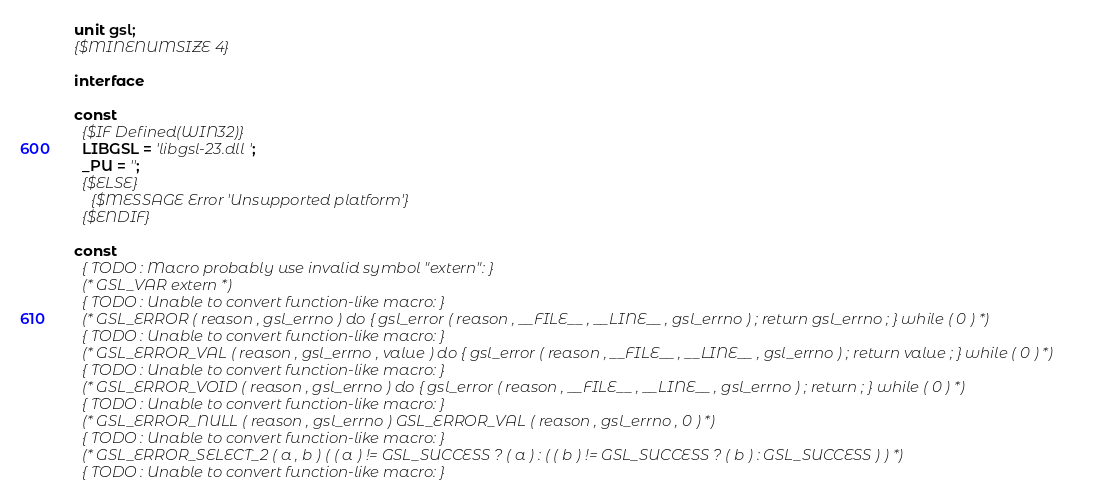Convert code to text. <code><loc_0><loc_0><loc_500><loc_500><_Pascal_>unit gsl;
{$MINENUMSIZE 4}

interface

const
  {$IF Defined(WIN32)}
  LIBGSL = 'libgsl-23.dll';
  _PU = '';
  {$ELSE}
    {$MESSAGE Error 'Unsupported platform'}
  {$ENDIF}

const
  { TODO : Macro probably use invalid symbol "extern": }
  (* GSL_VAR extern *)
  { TODO : Unable to convert function-like macro: }
  (* GSL_ERROR ( reason , gsl_errno ) do { gsl_error ( reason , __FILE__ , __LINE__ , gsl_errno ) ; return gsl_errno ; } while ( 0 ) *)
  { TODO : Unable to convert function-like macro: }
  (* GSL_ERROR_VAL ( reason , gsl_errno , value ) do { gsl_error ( reason , __FILE__ , __LINE__ , gsl_errno ) ; return value ; } while ( 0 ) *)
  { TODO : Unable to convert function-like macro: }
  (* GSL_ERROR_VOID ( reason , gsl_errno ) do { gsl_error ( reason , __FILE__ , __LINE__ , gsl_errno ) ; return ; } while ( 0 ) *)
  { TODO : Unable to convert function-like macro: }
  (* GSL_ERROR_NULL ( reason , gsl_errno ) GSL_ERROR_VAL ( reason , gsl_errno , 0 ) *)
  { TODO : Unable to convert function-like macro: }
  (* GSL_ERROR_SELECT_2 ( a , b ) ( ( a ) != GSL_SUCCESS ? ( a ) : ( ( b ) != GSL_SUCCESS ? ( b ) : GSL_SUCCESS ) ) *)
  { TODO : Unable to convert function-like macro: }</code> 